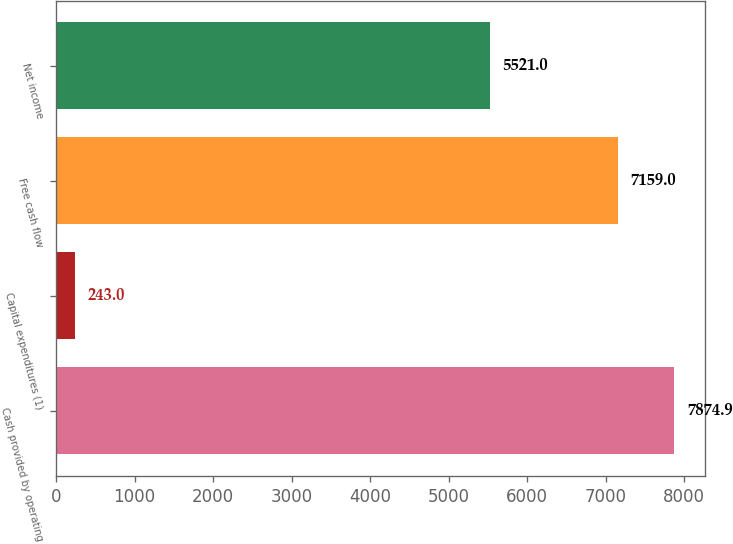<chart> <loc_0><loc_0><loc_500><loc_500><bar_chart><fcel>Cash provided by operating<fcel>Capital expenditures (1)<fcel>Free cash flow<fcel>Net income<nl><fcel>7874.9<fcel>243<fcel>7159<fcel>5521<nl></chart> 